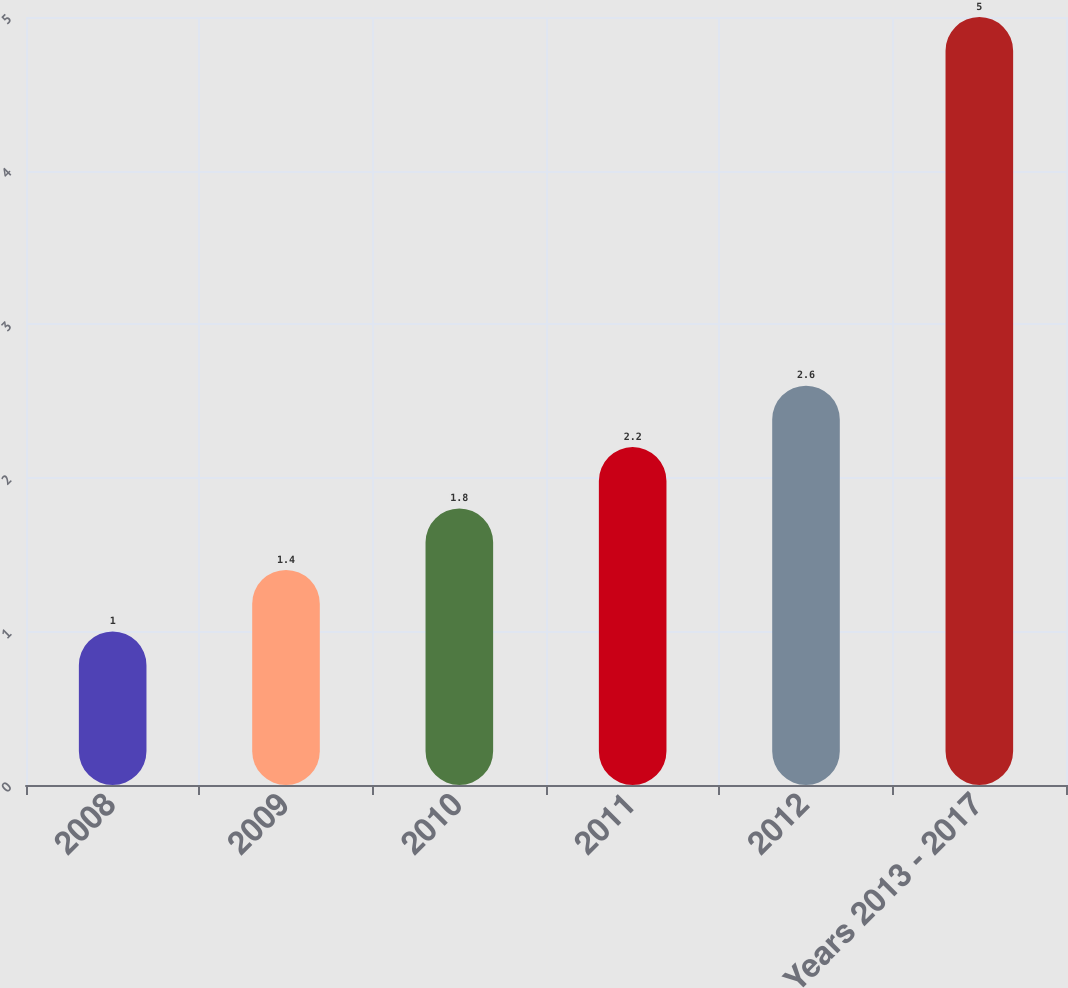<chart> <loc_0><loc_0><loc_500><loc_500><bar_chart><fcel>2008<fcel>2009<fcel>2010<fcel>2011<fcel>2012<fcel>Years 2013 - 2017<nl><fcel>1<fcel>1.4<fcel>1.8<fcel>2.2<fcel>2.6<fcel>5<nl></chart> 